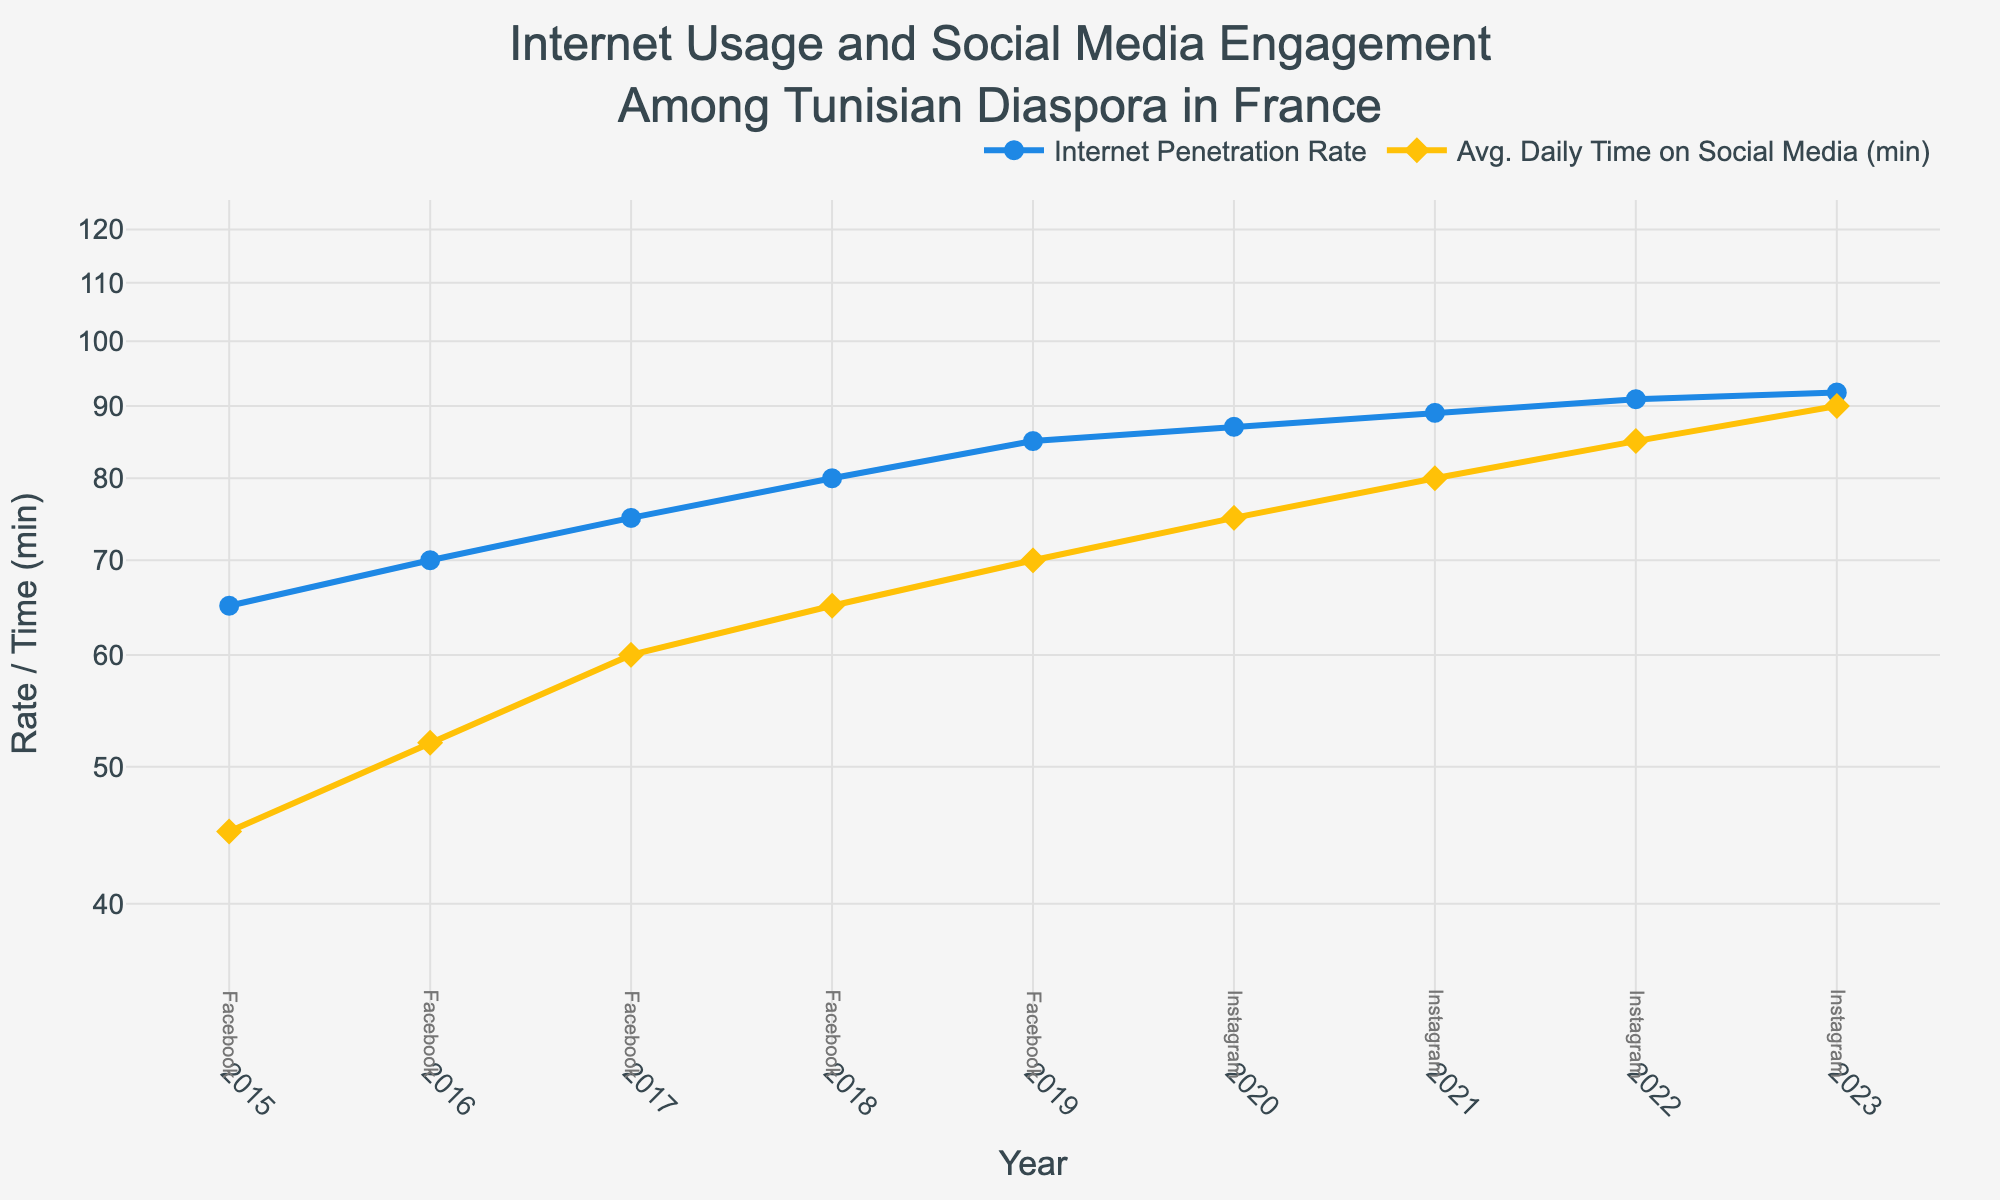What is the title of the figure? The title is prominently displayed at the top of the figure.
Answer: Internet Usage and Social Media Engagement Among Tunisian Diaspora in France How many years of data are shown in the plot? The x-axis represents years from 2015 to 2023. Counting each year, we have 9 data points.
Answer: 9 What was the Internet Penetration Rate in 2020? The blue line representing the Internet Penetration Rate intersects with the year 2020 at a point. By checking the y-axis value, we see that it’s 87%.
Answer: 87% Which social media platform was the top in 2019? Annotations below each year indicate the top social media platform. For 2019, it is labeled as Facebook.
Answer: Facebook During which year did Instagram become the top social media platform? By examining the annotations, we notice that the switch from Facebook to Instagram happens in the year 2020.
Answer: 2020 What was the increase in the Average Daily Time Spent On Social Media from 2015 to 2023? In 2015, the Average Daily Time was 45 minutes, and in 2023, it was 90 minutes. The difference is 90 - 45.
Answer: 45 minutes How does the Internet Penetration Rate trend appear across the years? Observing the blue line, the Internet Penetration Rate shows an upward trend from 2015 to 2023.
Answer: Increasing In which year did the Average Daily Time Spent On Social Media see the highest increase compared to the previous year? The yellow line shows the daily time on social media. The steepest increase is noticed between 2016 and 2017, jumping from 52 to 60 minutes.
Answer: 2017 How does the trend of Internet Penetration Rate compare to the Average Daily Time Spent On Social Media from 2015 to 2023? Both metrics show an increasing trend over the years, but the penetration rate increases more gradually compared to the sharper rise in daily social media time.
Answer: Both Increased, Social Media time increased sharper 